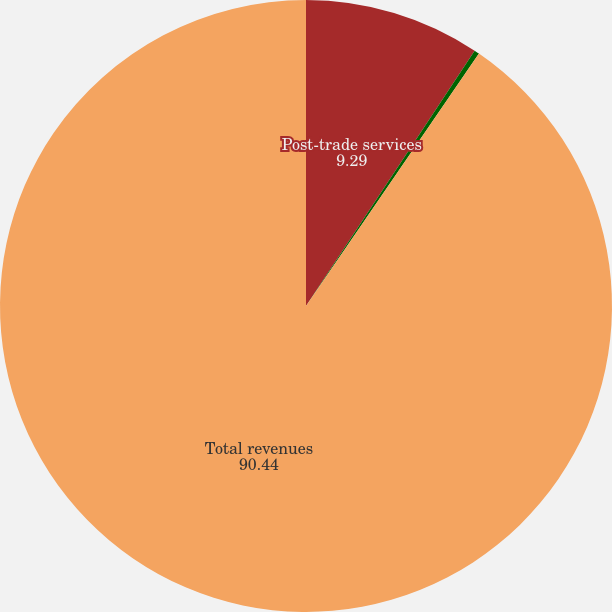Convert chart. <chart><loc_0><loc_0><loc_500><loc_500><pie_chart><fcel>Post-trade services<fcel>Other<fcel>Total revenues<nl><fcel>9.29%<fcel>0.27%<fcel>90.44%<nl></chart> 